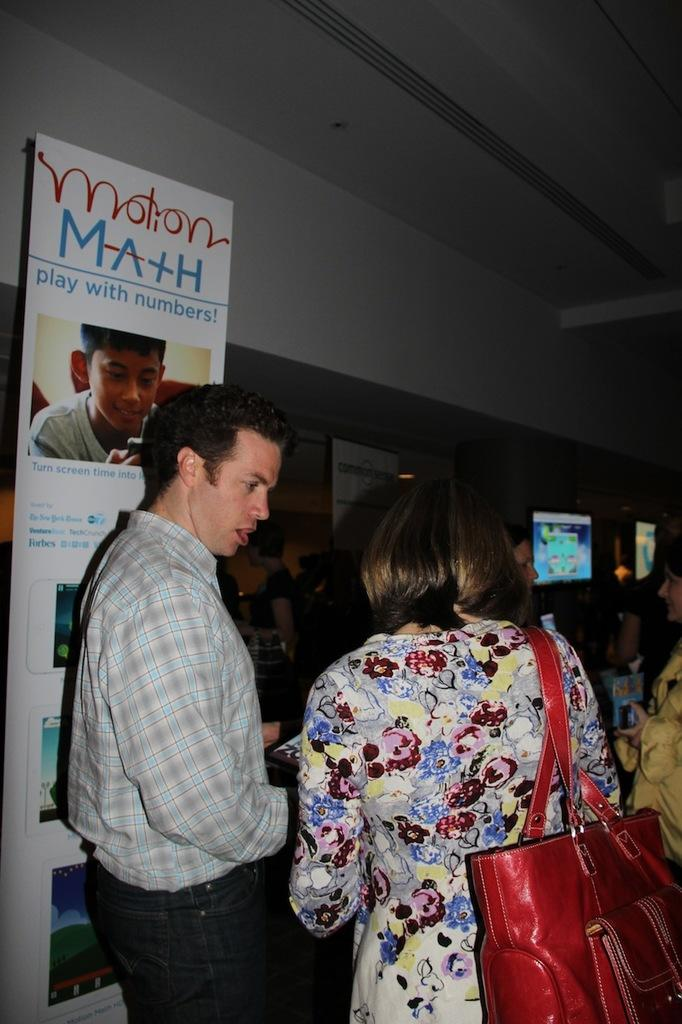What can be seen in the image involving people? There are people standing in the image. What is another object present in the image besides people? There is a poster in the image. What electronic device is visible in the image? There is a television in the image. What type of pan is being used to cook on the television in the image? There is no pan or cooking activity present in the image; it only features people, a poster, and a television. 